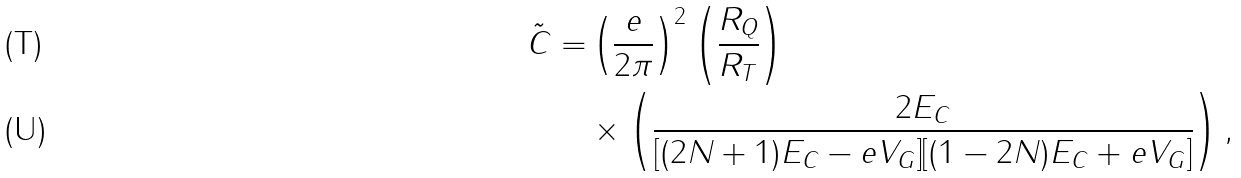Convert formula to latex. <formula><loc_0><loc_0><loc_500><loc_500>\tilde { C } = & \left ( \frac { e } { 2 \pi } \right ) ^ { 2 } \left ( \frac { R _ { Q } } { R _ { T } } \right ) \\ & \times \left ( \frac { 2 E _ { C } } { [ ( 2 N + 1 ) E _ { C } - e V _ { G } ] [ ( 1 - 2 N ) E _ { C } + e V _ { G } ] } \right ) ,</formula> 